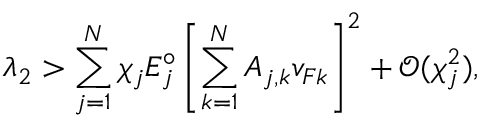Convert formula to latex. <formula><loc_0><loc_0><loc_500><loc_500>\lambda _ { 2 } > \sum _ { j = 1 } ^ { N } \chi _ { j } E _ { j } ^ { \circ } \left [ \sum _ { k = 1 } ^ { N } A _ { j , k } v _ { F k } \right ] ^ { 2 } + \mathcal { O } ( \chi _ { j } ^ { 2 } ) ,</formula> 